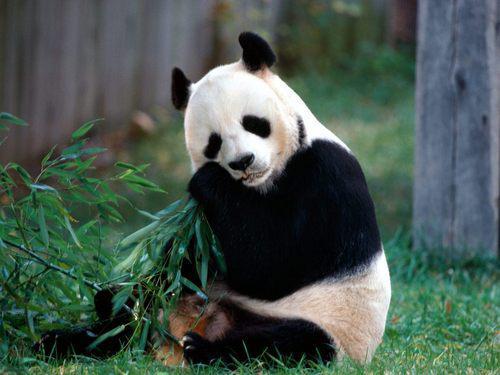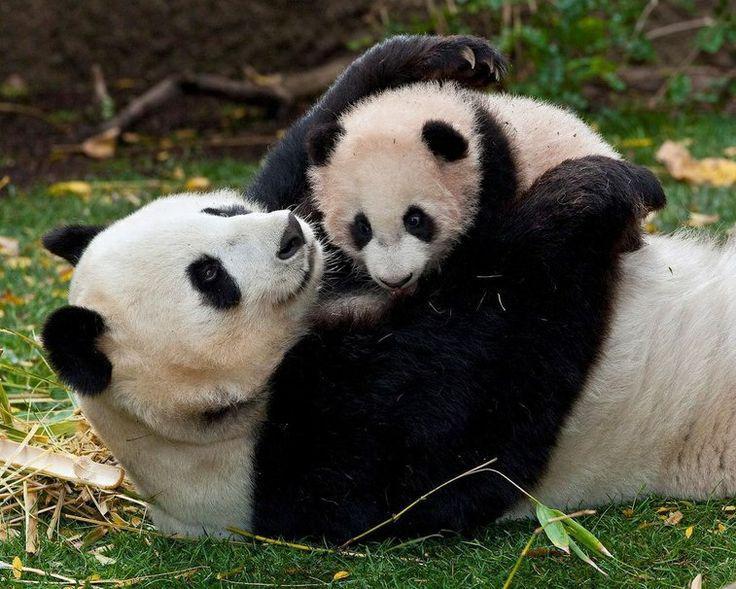The first image is the image on the left, the second image is the image on the right. Considering the images on both sides, is "A baby panda is resting on its mother's chest" valid? Answer yes or no. Yes. 